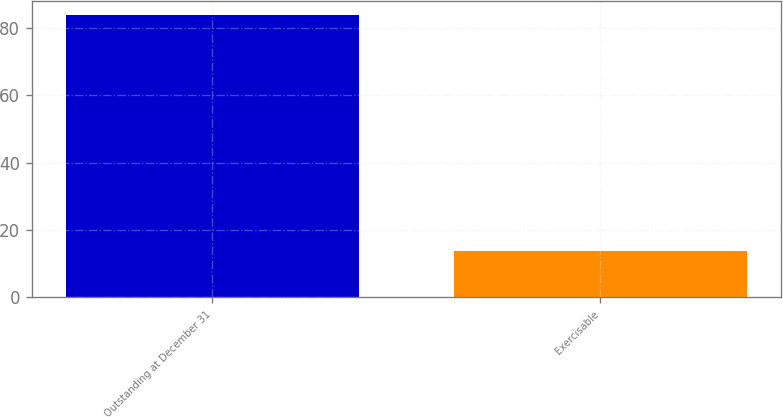Convert chart to OTSL. <chart><loc_0><loc_0><loc_500><loc_500><bar_chart><fcel>Outstanding at December 31<fcel>Exercisable<nl><fcel>83.8<fcel>13.8<nl></chart> 